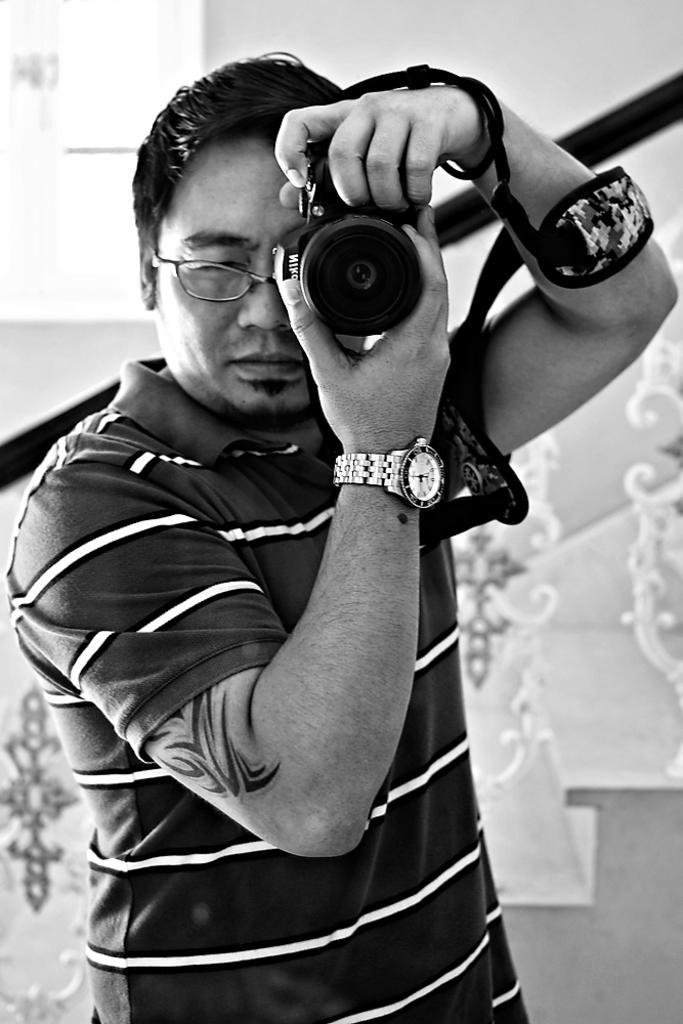How would you summarize this image in a sentence or two? As we can see in the image there is a man holding camera. 